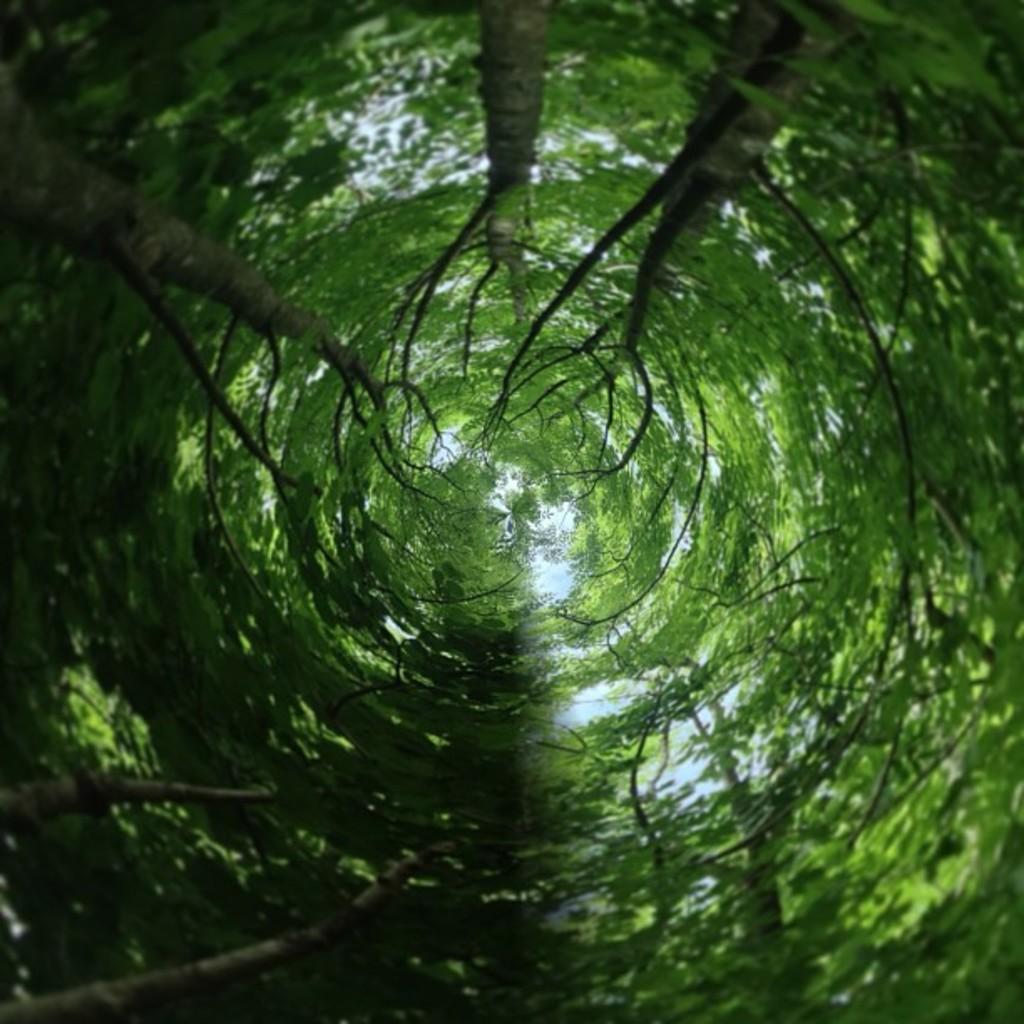Can you describe this image briefly? This is an edited image. There are trees and the sky in the image. 